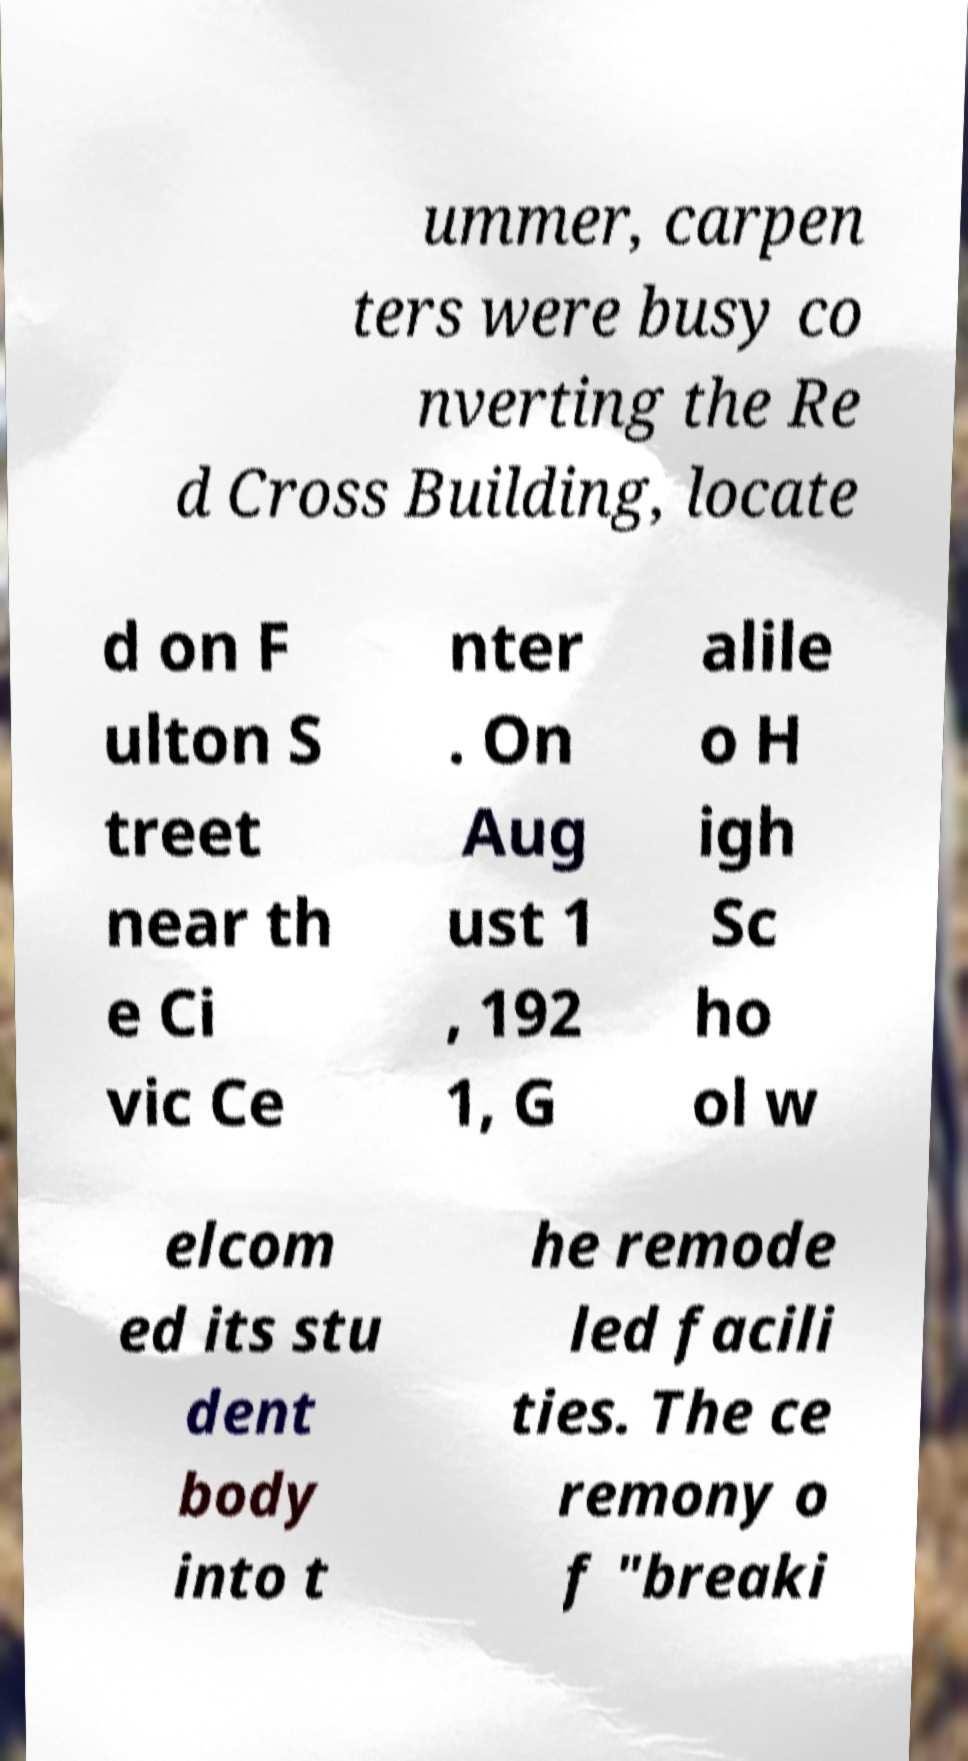Could you extract and type out the text from this image? ummer, carpen ters were busy co nverting the Re d Cross Building, locate d on F ulton S treet near th e Ci vic Ce nter . On Aug ust 1 , 192 1, G alile o H igh Sc ho ol w elcom ed its stu dent body into t he remode led facili ties. The ce remony o f "breaki 